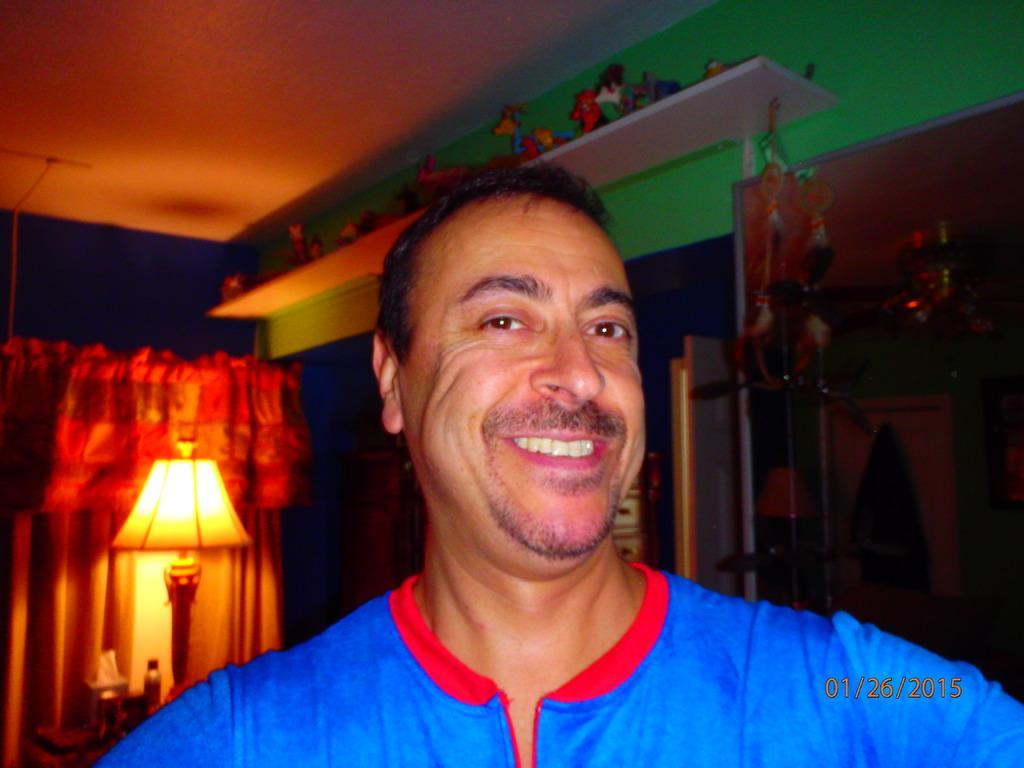Describe this image in one or two sentences. In this image, we can see a person is smiling and seeing. Background we can see curtains, table lamp, some objects, wall, few showpieces, shelf. Top of the image, there is a roof. Right side bottom, we can see a watermark represents date. 